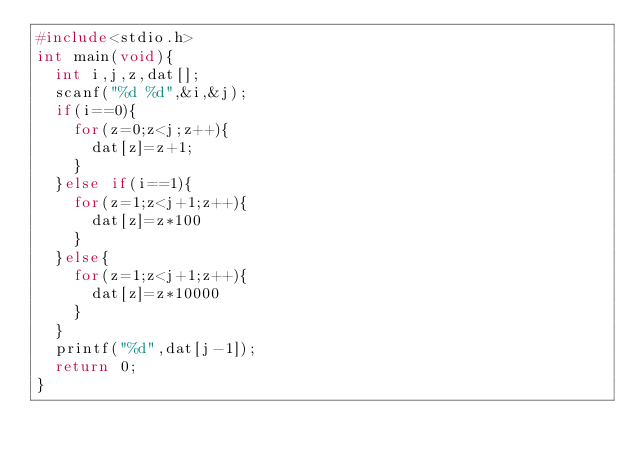<code> <loc_0><loc_0><loc_500><loc_500><_C_>#include<stdio.h>
int main(void){
	int i,j,z,dat[];
	scanf("%d %d",&i,&j);
	if(i==0){
		for(z=0;z<j;z++){
			dat[z]=z+1;
		}
	}else if(i==1){
		for(z=1;z<j+1;z++){
			dat[z]=z*100
		}
	}else{
		for(z=1;z<j+1;z++){
			dat[z]=z*10000
		}
	}
	printf("%d",dat[j-1]);
	return 0;
}</code> 